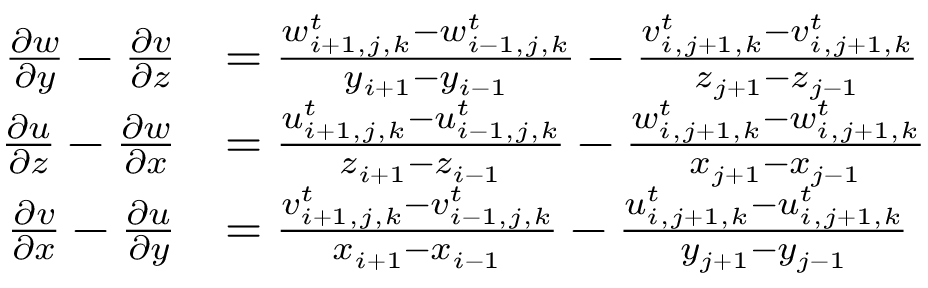Convert formula to latex. <formula><loc_0><loc_0><loc_500><loc_500>\begin{array} { r l } { \frac { \partial w } { \partial y } - \frac { \partial v } { \partial z } } & { = \frac { w _ { i + 1 , j , k } ^ { t } - w _ { i - 1 , j , k } ^ { t } } { y _ { i + 1 } - y _ { i - 1 } } - \frac { v _ { i , j + 1 , k } ^ { t } - v _ { i , j + 1 , k } ^ { t } } { z _ { j + 1 } - z _ { j - 1 } } } \\ { \frac { \partial u } { \partial z } - \frac { \partial w } { \partial x } } & { = \frac { u _ { i + 1 , j , k } ^ { t } - u _ { i - 1 , j , k } ^ { t } } { z _ { i + 1 } - z _ { i - 1 } } - \frac { w _ { i , j + 1 , k } ^ { t } - w _ { i , j + 1 , k } ^ { t } } { x _ { j + 1 } - x _ { j - 1 } } } \\ { \frac { \partial v } { \partial x } - \frac { \partial u } { \partial y } } & { = \frac { v _ { i + 1 , j , k } ^ { t } - v _ { i - 1 , j , k } ^ { t } } { x _ { i + 1 } - x _ { i - 1 } } - \frac { u _ { i , j + 1 , k } ^ { t } - u _ { i , j + 1 , k } ^ { t } } { y _ { j + 1 } - y _ { j - 1 } } } \end{array}</formula> 